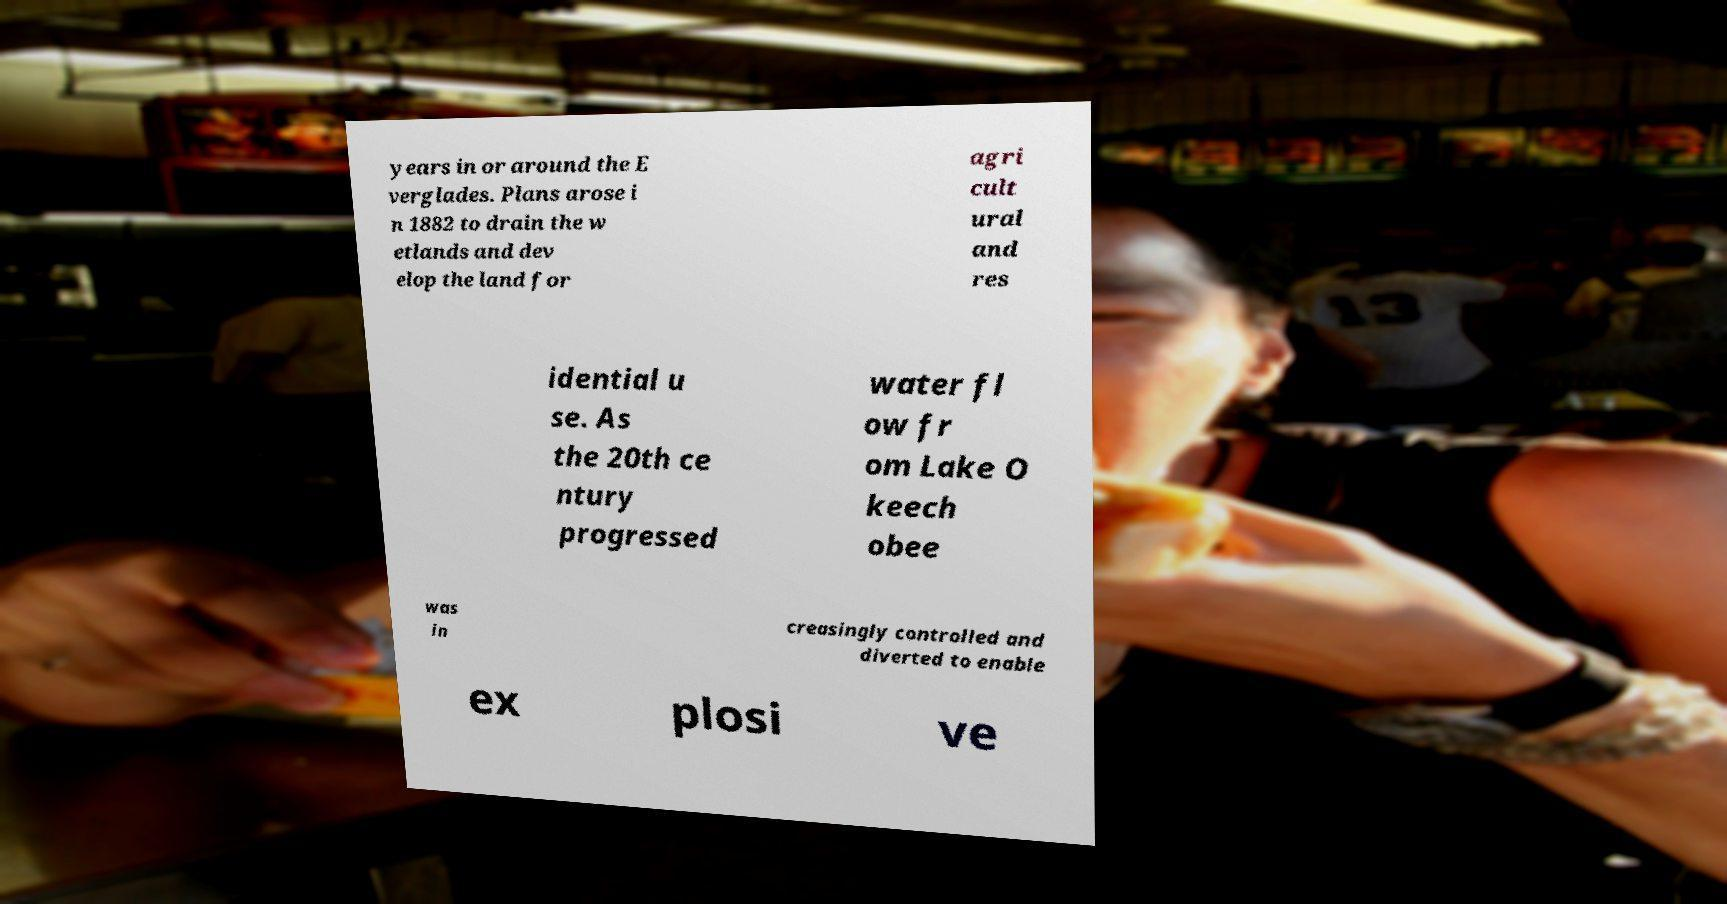For documentation purposes, I need the text within this image transcribed. Could you provide that? years in or around the E verglades. Plans arose i n 1882 to drain the w etlands and dev elop the land for agri cult ural and res idential u se. As the 20th ce ntury progressed water fl ow fr om Lake O keech obee was in creasingly controlled and diverted to enable ex plosi ve 